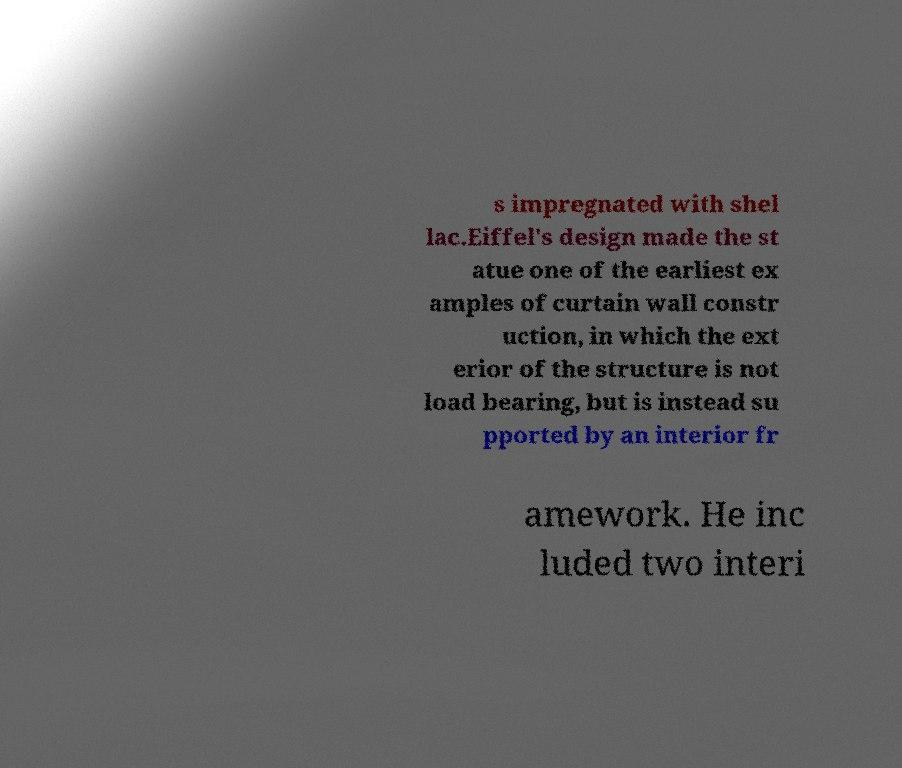There's text embedded in this image that I need extracted. Can you transcribe it verbatim? s impregnated with shel lac.Eiffel's design made the st atue one of the earliest ex amples of curtain wall constr uction, in which the ext erior of the structure is not load bearing, but is instead su pported by an interior fr amework. He inc luded two interi 